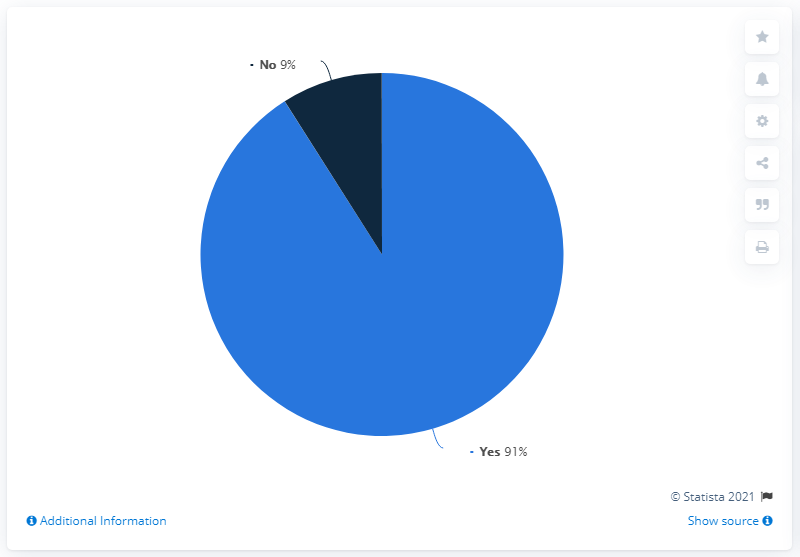Indicate a few pertinent items in this graphic. Nine people enjoyed their holiday plans in Mexico due to the COVID-19 pandemic. According to a survey conducted in Mexico in March 2020, 91% of respondents had cancelled or were planning to cancel their trips due to the COVID-19 pandemic. Nine-one people cancelled their holiday plans in Mexico due to COVID-19. 